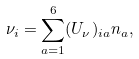Convert formula to latex. <formula><loc_0><loc_0><loc_500><loc_500>\nu _ { i } = \sum _ { a = 1 } ^ { 6 } ( U _ { \nu } ) _ { i a } n _ { a } ,</formula> 